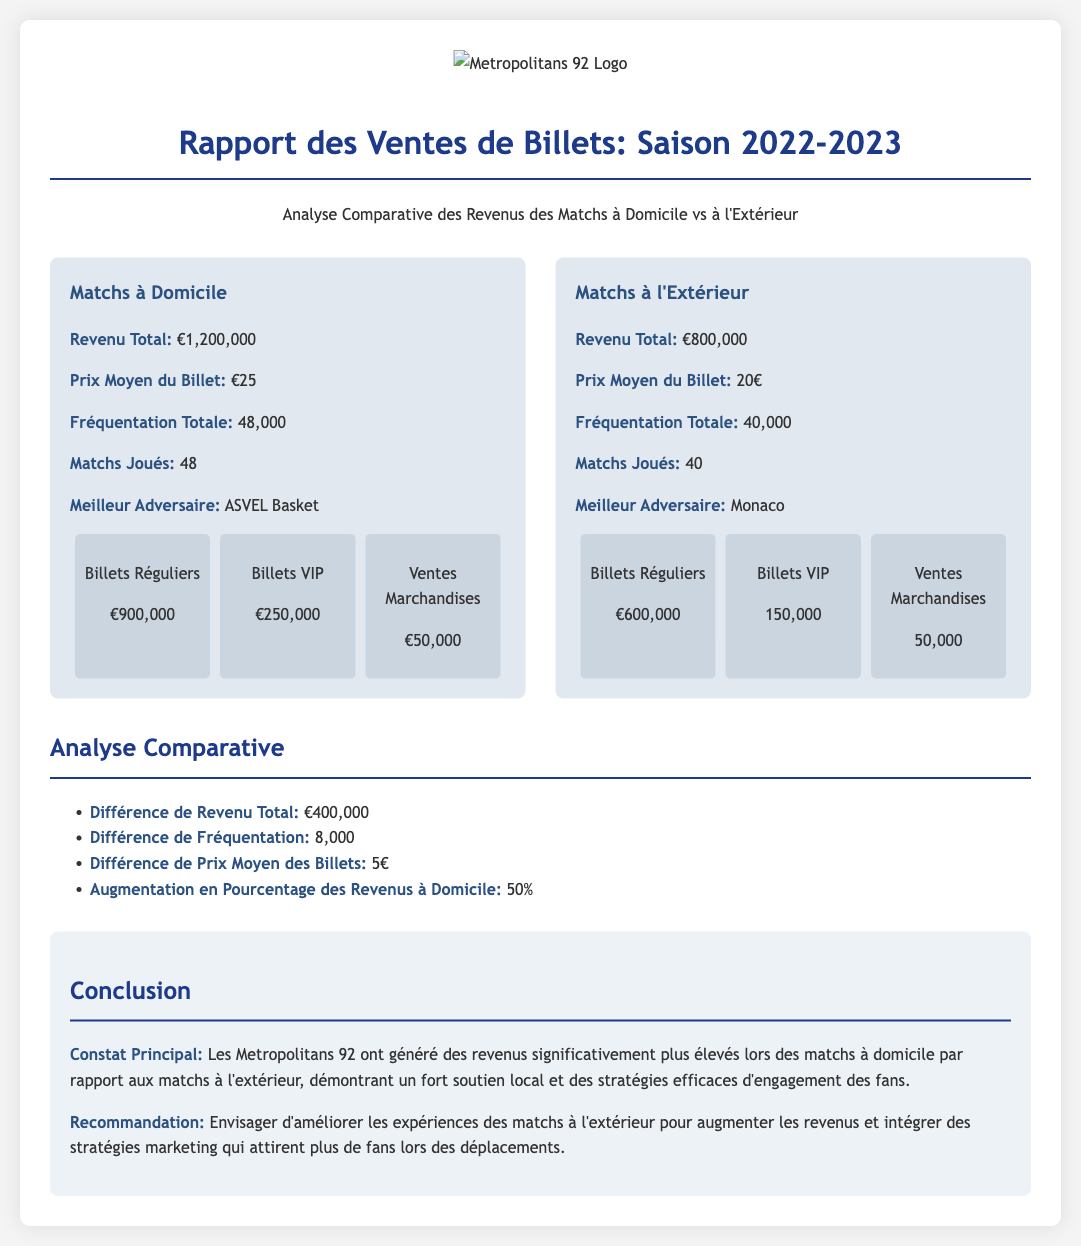what is the total revenue for home games? The document states that the total revenue for home games is €1,200,000.
Answer: €1,200,000 what is the average ticket price for away games? According to the report, the average ticket price for away games is €20.
Answer: €20 how many home games were played? The report indicates that 48 home games were played in the season.
Answer: 48 what is the difference in total revenue between home and away games? The document shows a total revenue difference of €400,000 between home and away games.
Answer: €400,000 who was the best opponent for home games? The best opponent for home games listed in the report is ASVEL Basket.
Answer: ASVEL Basket what is the percentage increase in revenue for home games? The report states there was a 50% increase in revenue for home games.
Answer: 50% how much revenue was generated from regular tickets for away games? The document mentions that €600,000 was generated from regular tickets for away games.
Answer: €600,000 what is the total attendance for home games? The total attendance for home games is stated as 48,000 in the report.
Answer: 48,000 what recommendation is made for improving revenue from away games? The document recommends enhancing game experiences for away matches to increase revenue.
Answer: Improve experiences 